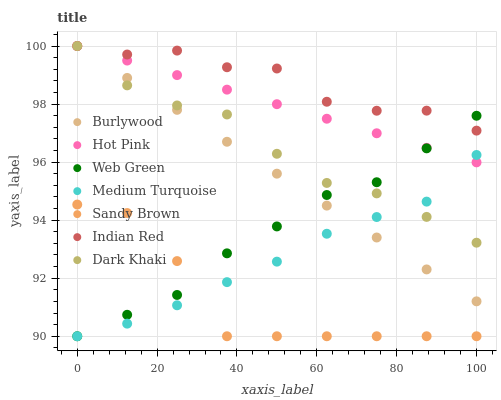Does Sandy Brown have the minimum area under the curve?
Answer yes or no. Yes. Does Indian Red have the maximum area under the curve?
Answer yes or no. Yes. Does Burlywood have the minimum area under the curve?
Answer yes or no. No. Does Burlywood have the maximum area under the curve?
Answer yes or no. No. Is Burlywood the smoothest?
Answer yes or no. Yes. Is Sandy Brown the roughest?
Answer yes or no. Yes. Is Hot Pink the smoothest?
Answer yes or no. No. Is Hot Pink the roughest?
Answer yes or no. No. Does Medium Turquoise have the lowest value?
Answer yes or no. Yes. Does Burlywood have the lowest value?
Answer yes or no. No. Does Indian Red have the highest value?
Answer yes or no. Yes. Does Web Green have the highest value?
Answer yes or no. No. Is Sandy Brown less than Burlywood?
Answer yes or no. Yes. Is Hot Pink greater than Sandy Brown?
Answer yes or no. Yes. Does Web Green intersect Sandy Brown?
Answer yes or no. Yes. Is Web Green less than Sandy Brown?
Answer yes or no. No. Is Web Green greater than Sandy Brown?
Answer yes or no. No. Does Sandy Brown intersect Burlywood?
Answer yes or no. No. 